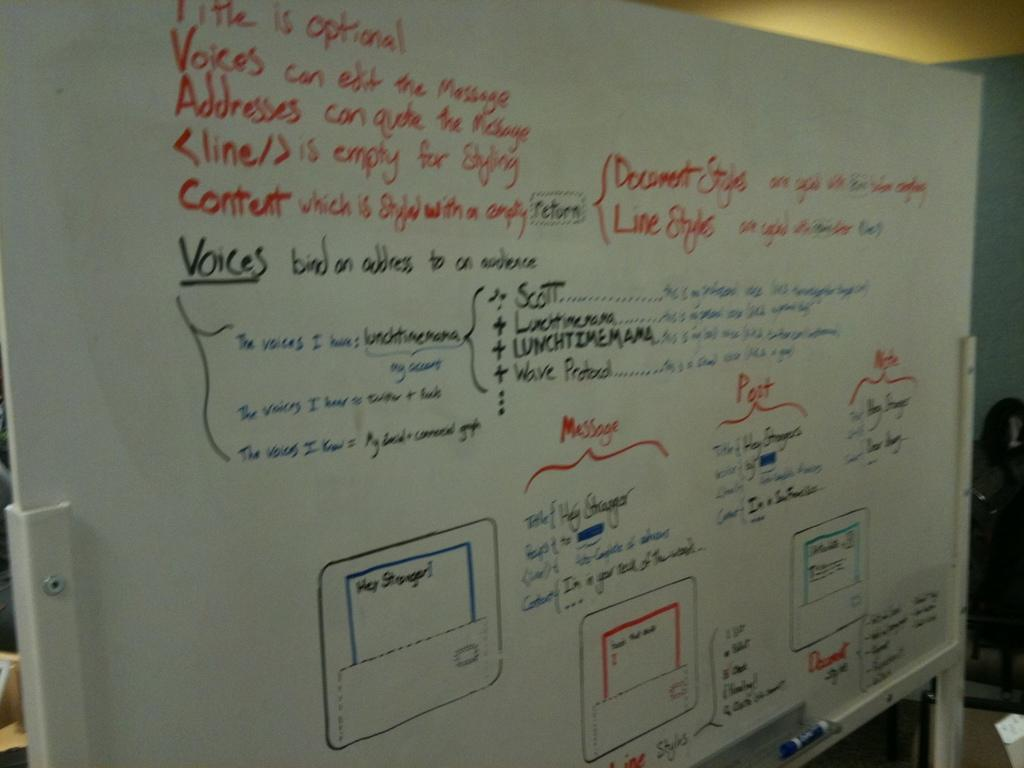<image>
Provide a brief description of the given image. A whiteboard with many guidelines written on it such as that the Title is optional. 